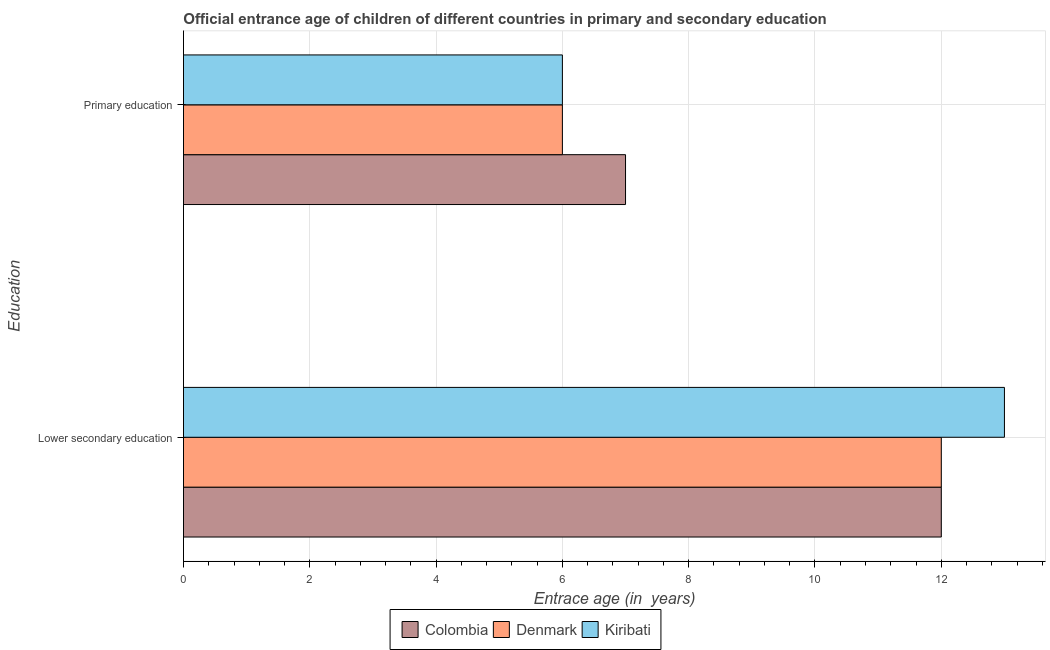Are the number of bars on each tick of the Y-axis equal?
Provide a short and direct response. Yes. How many bars are there on the 1st tick from the bottom?
Offer a terse response. 3. What is the label of the 2nd group of bars from the top?
Your response must be concise. Lower secondary education. What is the entrance age of chiildren in primary education in Kiribati?
Make the answer very short. 6. Across all countries, what is the maximum entrance age of children in lower secondary education?
Your answer should be compact. 13. Across all countries, what is the minimum entrance age of children in lower secondary education?
Your answer should be very brief. 12. In which country was the entrance age of children in lower secondary education maximum?
Give a very brief answer. Kiribati. What is the total entrance age of chiildren in primary education in the graph?
Give a very brief answer. 19. What is the difference between the entrance age of chiildren in primary education in Colombia and that in Denmark?
Make the answer very short. 1. What is the difference between the entrance age of chiildren in primary education in Denmark and the entrance age of children in lower secondary education in Colombia?
Provide a short and direct response. -6. What is the average entrance age of chiildren in primary education per country?
Your answer should be very brief. 6.33. What is the difference between the entrance age of children in lower secondary education and entrance age of chiildren in primary education in Kiribati?
Provide a succinct answer. 7. What is the ratio of the entrance age of chiildren in primary education in Denmark to that in Colombia?
Provide a short and direct response. 0.86. Is the entrance age of chiildren in primary education in Colombia less than that in Kiribati?
Give a very brief answer. No. What does the 3rd bar from the top in Primary education represents?
Offer a very short reply. Colombia. How many countries are there in the graph?
Give a very brief answer. 3. What is the difference between two consecutive major ticks on the X-axis?
Provide a succinct answer. 2. Are the values on the major ticks of X-axis written in scientific E-notation?
Provide a short and direct response. No. Does the graph contain any zero values?
Give a very brief answer. No. Does the graph contain grids?
Offer a terse response. Yes. How many legend labels are there?
Ensure brevity in your answer.  3. How are the legend labels stacked?
Keep it short and to the point. Horizontal. What is the title of the graph?
Provide a short and direct response. Official entrance age of children of different countries in primary and secondary education. Does "Netherlands" appear as one of the legend labels in the graph?
Provide a succinct answer. No. What is the label or title of the X-axis?
Ensure brevity in your answer.  Entrace age (in  years). What is the label or title of the Y-axis?
Ensure brevity in your answer.  Education. What is the Entrace age (in  years) of Colombia in Lower secondary education?
Your answer should be very brief. 12. What is the Entrace age (in  years) of Denmark in Lower secondary education?
Offer a very short reply. 12. What is the Entrace age (in  years) of Colombia in Primary education?
Ensure brevity in your answer.  7. Across all Education, what is the minimum Entrace age (in  years) of Kiribati?
Your answer should be compact. 6. What is the total Entrace age (in  years) in Colombia in the graph?
Provide a succinct answer. 19. What is the total Entrace age (in  years) in Denmark in the graph?
Provide a short and direct response. 18. What is the total Entrace age (in  years) of Kiribati in the graph?
Offer a terse response. 19. What is the difference between the Entrace age (in  years) in Colombia in Lower secondary education and the Entrace age (in  years) in Denmark in Primary education?
Provide a short and direct response. 6. What is the difference between the Entrace age (in  years) of Colombia in Lower secondary education and the Entrace age (in  years) of Kiribati in Primary education?
Your answer should be very brief. 6. What is the average Entrace age (in  years) in Denmark per Education?
Ensure brevity in your answer.  9. What is the difference between the Entrace age (in  years) of Denmark and Entrace age (in  years) of Kiribati in Lower secondary education?
Your response must be concise. -1. What is the difference between the Entrace age (in  years) of Colombia and Entrace age (in  years) of Denmark in Primary education?
Ensure brevity in your answer.  1. What is the difference between the Entrace age (in  years) in Colombia and Entrace age (in  years) in Kiribati in Primary education?
Offer a terse response. 1. What is the ratio of the Entrace age (in  years) in Colombia in Lower secondary education to that in Primary education?
Make the answer very short. 1.71. What is the ratio of the Entrace age (in  years) in Kiribati in Lower secondary education to that in Primary education?
Offer a very short reply. 2.17. What is the difference between the highest and the second highest Entrace age (in  years) in Kiribati?
Your answer should be compact. 7. What is the difference between the highest and the lowest Entrace age (in  years) of Denmark?
Give a very brief answer. 6. What is the difference between the highest and the lowest Entrace age (in  years) of Kiribati?
Make the answer very short. 7. 